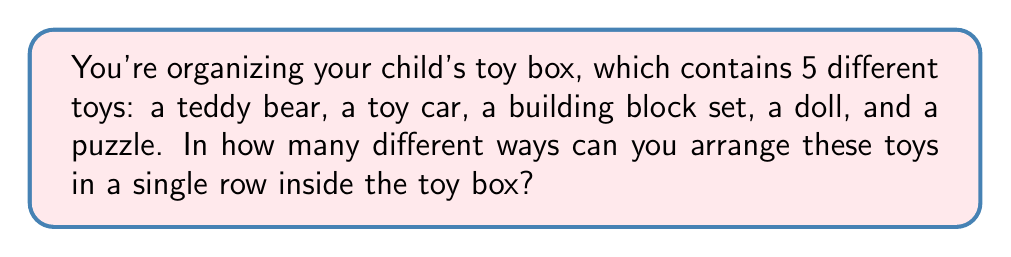Help me with this question. Let's approach this step-by-step:

1) This is a permutation problem. We need to arrange 5 distinct objects (toys) in a specific order.

2) For the first position, we have 5 choices of toys to place.

3) After placing the first toy, we have 4 choices for the second position.

4) For the third position, we'll have 3 choices left.

5) For the fourth position, we'll have 2 choices.

6) For the last position, we'll only have 1 toy left to place.

7) According to the multiplication principle, the total number of ways to arrange these toys is:

   $$5 \times 4 \times 3 \times 2 \times 1 = 120$$

8) This is also known as 5 factorial, written as 5!:

   $$5! = 5 \times 4 \times 3 \times 2 \times 1 = 120$$

Therefore, there are 120 different ways to arrange the 5 toys in the toy box.
Answer: 120 